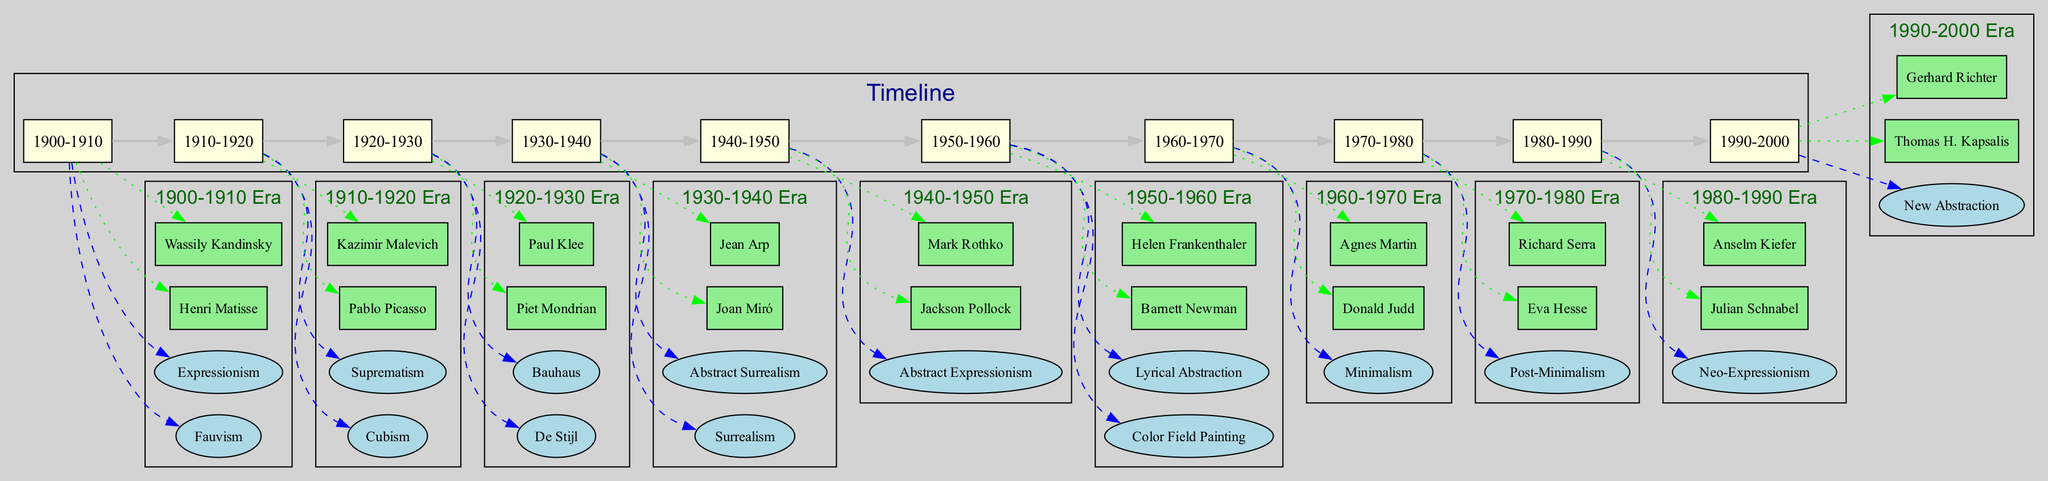What are the key movements in the decade 1940-1950? In the timeline, we look at the box that represents the decade 1940-1950. It shows one movement listed as "Abstract Expressionism" under the key movements for that period.
Answer: Abstract Expressionism How many artists are associated with the decade 1920-1930? By examining the decade 1920-1930, we see two artists listed: Piet Mondrian and Paul Klee. Therefore, the total count of artists for this period is two.
Answer: 2 Which artist is linked to the New Abstraction movement? In the timeline section for the decade 1990-2000, the movement titled "New Abstraction" is connected to the artist named Thomas H. Kapsalis.
Answer: Thomas H. Kapsalis What is the relationship between Cubism and Pablo Picasso? The diagram indicates that Cubism, a key movement in the decade 1910-1920, is linked directly to Pablo Picasso through a dotted edge connection, showcasing his association with this movement.
Answer: Pablo Picasso In which decade did Minimalism emerge? If we scan through the timeline, we see that Minimalism is highlighted as a key movement in the decade 1960-1970.
Answer: 1960-1970 How many key movements were prominent in the decade 1980-1990? Evaluating the decade 1980-1990 reveals only one key movement, which is Neo-Expressionism. Therefore, the count of key movements for this period is one.
Answer: 1 Which movement is related to Joan Miró? By identifying Joan Miró in the diagram, we find that he is connected to the movements listed under the decade 1930-1940, specifically "Surrealism".
Answer: Surrealism Who are the key artists listed for the decade 1950-1960? In examining the decade 1950-1960 in the diagram, we identify two key artists: Barnett Newman and Helen Frankenthaler, who are both marked under that era.
Answer: Barnett Newman, Helen Frankenthaler 